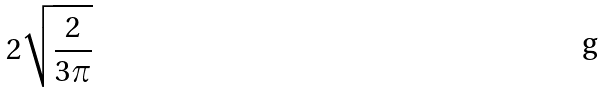<formula> <loc_0><loc_0><loc_500><loc_500>2 \sqrt { \frac { 2 } { 3 \pi } }</formula> 